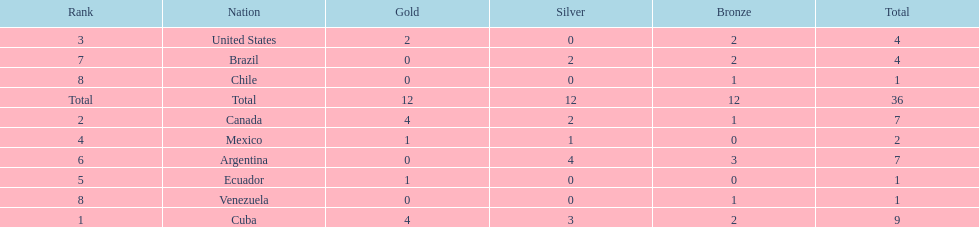Which nation won gold but did not win silver? United States. 